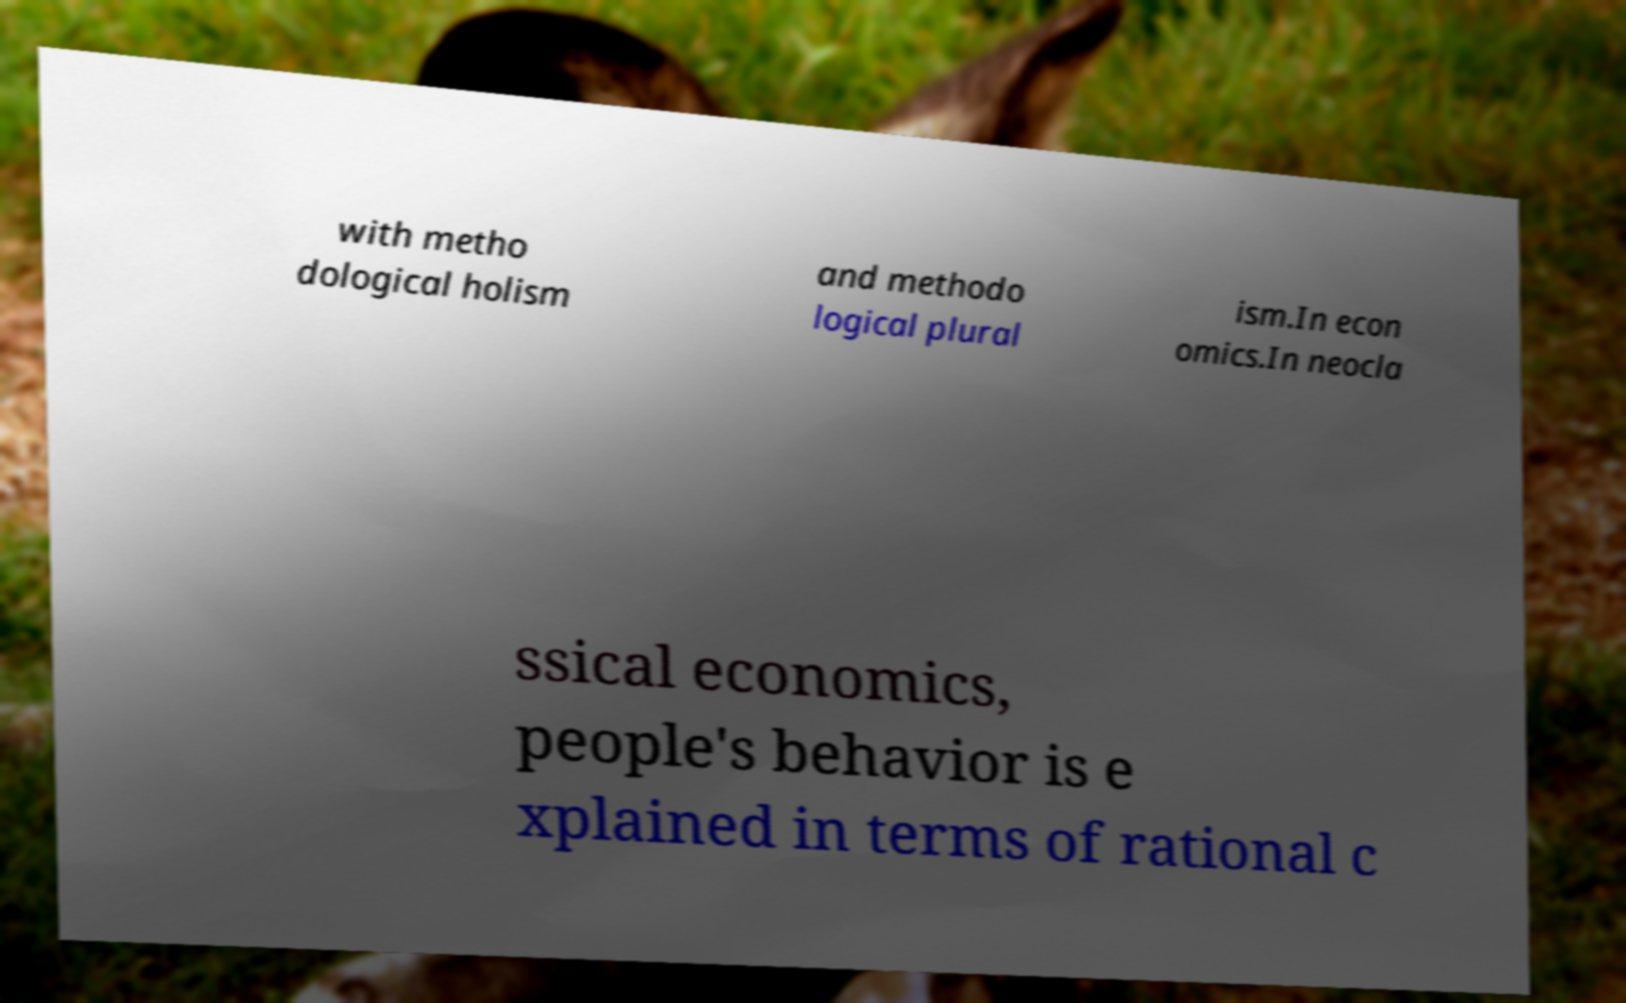For documentation purposes, I need the text within this image transcribed. Could you provide that? with metho dological holism and methodo logical plural ism.In econ omics.In neocla ssical economics, people's behavior is e xplained in terms of rational c 